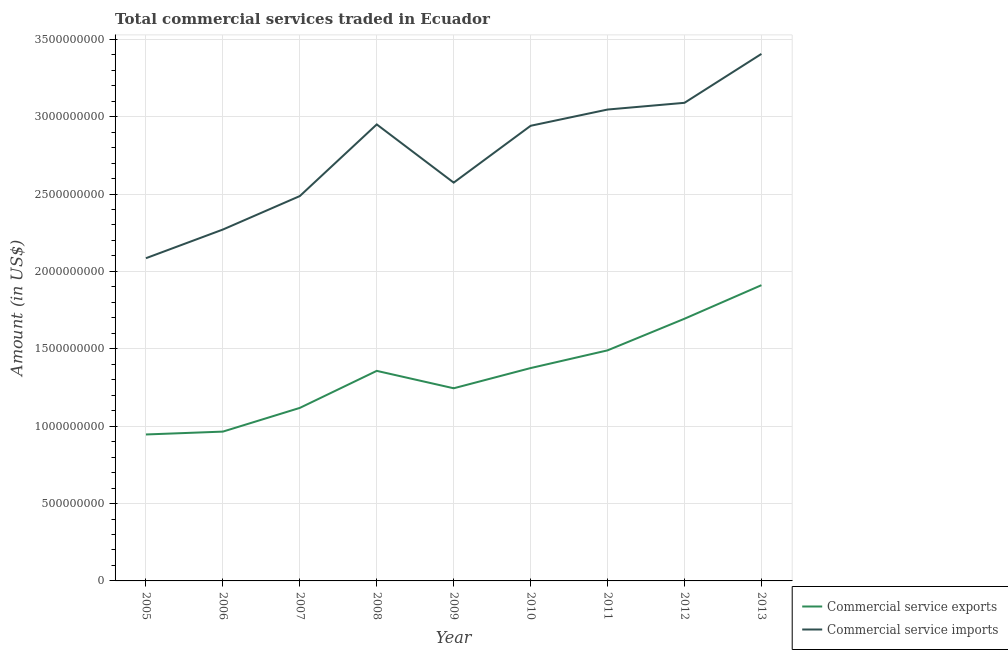How many different coloured lines are there?
Offer a very short reply. 2. Does the line corresponding to amount of commercial service imports intersect with the line corresponding to amount of commercial service exports?
Give a very brief answer. No. Is the number of lines equal to the number of legend labels?
Offer a terse response. Yes. What is the amount of commercial service exports in 2007?
Provide a short and direct response. 1.12e+09. Across all years, what is the maximum amount of commercial service exports?
Your response must be concise. 1.91e+09. Across all years, what is the minimum amount of commercial service imports?
Provide a succinct answer. 2.09e+09. In which year was the amount of commercial service exports maximum?
Make the answer very short. 2013. What is the total amount of commercial service imports in the graph?
Provide a succinct answer. 2.48e+1. What is the difference between the amount of commercial service imports in 2007 and that in 2012?
Your answer should be compact. -6.03e+08. What is the difference between the amount of commercial service imports in 2011 and the amount of commercial service exports in 2009?
Provide a short and direct response. 1.80e+09. What is the average amount of commercial service exports per year?
Keep it short and to the point. 1.34e+09. In the year 2005, what is the difference between the amount of commercial service exports and amount of commercial service imports?
Offer a terse response. -1.14e+09. What is the ratio of the amount of commercial service imports in 2008 to that in 2011?
Offer a terse response. 0.97. What is the difference between the highest and the second highest amount of commercial service exports?
Offer a very short reply. 2.17e+08. What is the difference between the highest and the lowest amount of commercial service imports?
Offer a very short reply. 1.32e+09. Is the sum of the amount of commercial service exports in 2006 and 2009 greater than the maximum amount of commercial service imports across all years?
Your answer should be very brief. No. Does the amount of commercial service imports monotonically increase over the years?
Keep it short and to the point. No. How many lines are there?
Your answer should be compact. 2. Does the graph contain any zero values?
Your response must be concise. No. Does the graph contain grids?
Your response must be concise. Yes. Where does the legend appear in the graph?
Your answer should be compact. Bottom right. What is the title of the graph?
Ensure brevity in your answer.  Total commercial services traded in Ecuador. What is the label or title of the X-axis?
Give a very brief answer. Year. What is the Amount (in US$) of Commercial service exports in 2005?
Give a very brief answer. 9.46e+08. What is the Amount (in US$) in Commercial service imports in 2005?
Make the answer very short. 2.09e+09. What is the Amount (in US$) in Commercial service exports in 2006?
Keep it short and to the point. 9.65e+08. What is the Amount (in US$) of Commercial service imports in 2006?
Keep it short and to the point. 2.27e+09. What is the Amount (in US$) of Commercial service exports in 2007?
Keep it short and to the point. 1.12e+09. What is the Amount (in US$) in Commercial service imports in 2007?
Your answer should be compact. 2.49e+09. What is the Amount (in US$) in Commercial service exports in 2008?
Ensure brevity in your answer.  1.36e+09. What is the Amount (in US$) in Commercial service imports in 2008?
Provide a short and direct response. 2.95e+09. What is the Amount (in US$) in Commercial service exports in 2009?
Offer a very short reply. 1.24e+09. What is the Amount (in US$) in Commercial service imports in 2009?
Give a very brief answer. 2.57e+09. What is the Amount (in US$) in Commercial service exports in 2010?
Your response must be concise. 1.38e+09. What is the Amount (in US$) in Commercial service imports in 2010?
Your answer should be very brief. 2.94e+09. What is the Amount (in US$) in Commercial service exports in 2011?
Your response must be concise. 1.49e+09. What is the Amount (in US$) of Commercial service imports in 2011?
Ensure brevity in your answer.  3.05e+09. What is the Amount (in US$) of Commercial service exports in 2012?
Ensure brevity in your answer.  1.69e+09. What is the Amount (in US$) of Commercial service imports in 2012?
Offer a very short reply. 3.09e+09. What is the Amount (in US$) in Commercial service exports in 2013?
Your answer should be very brief. 1.91e+09. What is the Amount (in US$) of Commercial service imports in 2013?
Your answer should be very brief. 3.41e+09. Across all years, what is the maximum Amount (in US$) in Commercial service exports?
Your answer should be very brief. 1.91e+09. Across all years, what is the maximum Amount (in US$) of Commercial service imports?
Make the answer very short. 3.41e+09. Across all years, what is the minimum Amount (in US$) in Commercial service exports?
Offer a terse response. 9.46e+08. Across all years, what is the minimum Amount (in US$) in Commercial service imports?
Give a very brief answer. 2.09e+09. What is the total Amount (in US$) in Commercial service exports in the graph?
Offer a very short reply. 1.21e+1. What is the total Amount (in US$) of Commercial service imports in the graph?
Your answer should be very brief. 2.48e+1. What is the difference between the Amount (in US$) in Commercial service exports in 2005 and that in 2006?
Ensure brevity in your answer.  -1.85e+07. What is the difference between the Amount (in US$) of Commercial service imports in 2005 and that in 2006?
Your response must be concise. -1.85e+08. What is the difference between the Amount (in US$) in Commercial service exports in 2005 and that in 2007?
Offer a very short reply. -1.72e+08. What is the difference between the Amount (in US$) in Commercial service imports in 2005 and that in 2007?
Your answer should be compact. -4.02e+08. What is the difference between the Amount (in US$) in Commercial service exports in 2005 and that in 2008?
Ensure brevity in your answer.  -4.11e+08. What is the difference between the Amount (in US$) of Commercial service imports in 2005 and that in 2008?
Make the answer very short. -8.64e+08. What is the difference between the Amount (in US$) in Commercial service exports in 2005 and that in 2009?
Offer a very short reply. -2.99e+08. What is the difference between the Amount (in US$) of Commercial service imports in 2005 and that in 2009?
Your answer should be compact. -4.88e+08. What is the difference between the Amount (in US$) of Commercial service exports in 2005 and that in 2010?
Your response must be concise. -4.29e+08. What is the difference between the Amount (in US$) of Commercial service imports in 2005 and that in 2010?
Make the answer very short. -8.56e+08. What is the difference between the Amount (in US$) in Commercial service exports in 2005 and that in 2011?
Keep it short and to the point. -5.44e+08. What is the difference between the Amount (in US$) of Commercial service imports in 2005 and that in 2011?
Your answer should be very brief. -9.61e+08. What is the difference between the Amount (in US$) in Commercial service exports in 2005 and that in 2012?
Keep it short and to the point. -7.48e+08. What is the difference between the Amount (in US$) in Commercial service imports in 2005 and that in 2012?
Give a very brief answer. -1.00e+09. What is the difference between the Amount (in US$) in Commercial service exports in 2005 and that in 2013?
Offer a very short reply. -9.65e+08. What is the difference between the Amount (in US$) in Commercial service imports in 2005 and that in 2013?
Provide a succinct answer. -1.32e+09. What is the difference between the Amount (in US$) of Commercial service exports in 2006 and that in 2007?
Provide a short and direct response. -1.53e+08. What is the difference between the Amount (in US$) in Commercial service imports in 2006 and that in 2007?
Keep it short and to the point. -2.16e+08. What is the difference between the Amount (in US$) of Commercial service exports in 2006 and that in 2008?
Offer a very short reply. -3.93e+08. What is the difference between the Amount (in US$) in Commercial service imports in 2006 and that in 2008?
Offer a very short reply. -6.79e+08. What is the difference between the Amount (in US$) in Commercial service exports in 2006 and that in 2009?
Ensure brevity in your answer.  -2.80e+08. What is the difference between the Amount (in US$) in Commercial service imports in 2006 and that in 2009?
Give a very brief answer. -3.03e+08. What is the difference between the Amount (in US$) of Commercial service exports in 2006 and that in 2010?
Offer a very short reply. -4.11e+08. What is the difference between the Amount (in US$) in Commercial service imports in 2006 and that in 2010?
Provide a succinct answer. -6.70e+08. What is the difference between the Amount (in US$) in Commercial service exports in 2006 and that in 2011?
Offer a very short reply. -5.25e+08. What is the difference between the Amount (in US$) of Commercial service imports in 2006 and that in 2011?
Give a very brief answer. -7.75e+08. What is the difference between the Amount (in US$) of Commercial service exports in 2006 and that in 2012?
Ensure brevity in your answer.  -7.29e+08. What is the difference between the Amount (in US$) in Commercial service imports in 2006 and that in 2012?
Provide a short and direct response. -8.19e+08. What is the difference between the Amount (in US$) in Commercial service exports in 2006 and that in 2013?
Keep it short and to the point. -9.46e+08. What is the difference between the Amount (in US$) of Commercial service imports in 2006 and that in 2013?
Your answer should be compact. -1.13e+09. What is the difference between the Amount (in US$) of Commercial service exports in 2007 and that in 2008?
Your answer should be very brief. -2.39e+08. What is the difference between the Amount (in US$) of Commercial service imports in 2007 and that in 2008?
Ensure brevity in your answer.  -4.63e+08. What is the difference between the Amount (in US$) in Commercial service exports in 2007 and that in 2009?
Keep it short and to the point. -1.27e+08. What is the difference between the Amount (in US$) of Commercial service imports in 2007 and that in 2009?
Your answer should be very brief. -8.68e+07. What is the difference between the Amount (in US$) of Commercial service exports in 2007 and that in 2010?
Ensure brevity in your answer.  -2.57e+08. What is the difference between the Amount (in US$) in Commercial service imports in 2007 and that in 2010?
Ensure brevity in your answer.  -4.54e+08. What is the difference between the Amount (in US$) in Commercial service exports in 2007 and that in 2011?
Give a very brief answer. -3.72e+08. What is the difference between the Amount (in US$) of Commercial service imports in 2007 and that in 2011?
Give a very brief answer. -5.59e+08. What is the difference between the Amount (in US$) in Commercial service exports in 2007 and that in 2012?
Your answer should be very brief. -5.76e+08. What is the difference between the Amount (in US$) of Commercial service imports in 2007 and that in 2012?
Provide a short and direct response. -6.03e+08. What is the difference between the Amount (in US$) in Commercial service exports in 2007 and that in 2013?
Make the answer very short. -7.93e+08. What is the difference between the Amount (in US$) in Commercial service imports in 2007 and that in 2013?
Your answer should be compact. -9.19e+08. What is the difference between the Amount (in US$) in Commercial service exports in 2008 and that in 2009?
Your response must be concise. 1.13e+08. What is the difference between the Amount (in US$) of Commercial service imports in 2008 and that in 2009?
Keep it short and to the point. 3.76e+08. What is the difference between the Amount (in US$) in Commercial service exports in 2008 and that in 2010?
Provide a short and direct response. -1.81e+07. What is the difference between the Amount (in US$) in Commercial service imports in 2008 and that in 2010?
Give a very brief answer. 8.76e+06. What is the difference between the Amount (in US$) in Commercial service exports in 2008 and that in 2011?
Keep it short and to the point. -1.32e+08. What is the difference between the Amount (in US$) in Commercial service imports in 2008 and that in 2011?
Provide a short and direct response. -9.62e+07. What is the difference between the Amount (in US$) of Commercial service exports in 2008 and that in 2012?
Give a very brief answer. -3.37e+08. What is the difference between the Amount (in US$) in Commercial service imports in 2008 and that in 2012?
Your response must be concise. -1.40e+08. What is the difference between the Amount (in US$) of Commercial service exports in 2008 and that in 2013?
Give a very brief answer. -5.54e+08. What is the difference between the Amount (in US$) in Commercial service imports in 2008 and that in 2013?
Make the answer very short. -4.56e+08. What is the difference between the Amount (in US$) in Commercial service exports in 2009 and that in 2010?
Keep it short and to the point. -1.31e+08. What is the difference between the Amount (in US$) in Commercial service imports in 2009 and that in 2010?
Your answer should be compact. -3.67e+08. What is the difference between the Amount (in US$) of Commercial service exports in 2009 and that in 2011?
Offer a very short reply. -2.45e+08. What is the difference between the Amount (in US$) of Commercial service imports in 2009 and that in 2011?
Your answer should be very brief. -4.72e+08. What is the difference between the Amount (in US$) in Commercial service exports in 2009 and that in 2012?
Give a very brief answer. -4.49e+08. What is the difference between the Amount (in US$) in Commercial service imports in 2009 and that in 2012?
Offer a terse response. -5.16e+08. What is the difference between the Amount (in US$) of Commercial service exports in 2009 and that in 2013?
Make the answer very short. -6.66e+08. What is the difference between the Amount (in US$) of Commercial service imports in 2009 and that in 2013?
Give a very brief answer. -8.32e+08. What is the difference between the Amount (in US$) of Commercial service exports in 2010 and that in 2011?
Give a very brief answer. -1.14e+08. What is the difference between the Amount (in US$) in Commercial service imports in 2010 and that in 2011?
Your answer should be very brief. -1.05e+08. What is the difference between the Amount (in US$) in Commercial service exports in 2010 and that in 2012?
Give a very brief answer. -3.19e+08. What is the difference between the Amount (in US$) in Commercial service imports in 2010 and that in 2012?
Make the answer very short. -1.48e+08. What is the difference between the Amount (in US$) of Commercial service exports in 2010 and that in 2013?
Your answer should be compact. -5.36e+08. What is the difference between the Amount (in US$) of Commercial service imports in 2010 and that in 2013?
Make the answer very short. -4.64e+08. What is the difference between the Amount (in US$) in Commercial service exports in 2011 and that in 2012?
Ensure brevity in your answer.  -2.04e+08. What is the difference between the Amount (in US$) of Commercial service imports in 2011 and that in 2012?
Keep it short and to the point. -4.35e+07. What is the difference between the Amount (in US$) in Commercial service exports in 2011 and that in 2013?
Your answer should be compact. -4.21e+08. What is the difference between the Amount (in US$) in Commercial service imports in 2011 and that in 2013?
Your answer should be compact. -3.59e+08. What is the difference between the Amount (in US$) of Commercial service exports in 2012 and that in 2013?
Ensure brevity in your answer.  -2.17e+08. What is the difference between the Amount (in US$) in Commercial service imports in 2012 and that in 2013?
Your answer should be very brief. -3.16e+08. What is the difference between the Amount (in US$) of Commercial service exports in 2005 and the Amount (in US$) of Commercial service imports in 2006?
Ensure brevity in your answer.  -1.32e+09. What is the difference between the Amount (in US$) of Commercial service exports in 2005 and the Amount (in US$) of Commercial service imports in 2007?
Offer a terse response. -1.54e+09. What is the difference between the Amount (in US$) of Commercial service exports in 2005 and the Amount (in US$) of Commercial service imports in 2008?
Keep it short and to the point. -2.00e+09. What is the difference between the Amount (in US$) in Commercial service exports in 2005 and the Amount (in US$) in Commercial service imports in 2009?
Ensure brevity in your answer.  -1.63e+09. What is the difference between the Amount (in US$) in Commercial service exports in 2005 and the Amount (in US$) in Commercial service imports in 2010?
Make the answer very short. -1.99e+09. What is the difference between the Amount (in US$) of Commercial service exports in 2005 and the Amount (in US$) of Commercial service imports in 2011?
Keep it short and to the point. -2.10e+09. What is the difference between the Amount (in US$) of Commercial service exports in 2005 and the Amount (in US$) of Commercial service imports in 2012?
Your answer should be compact. -2.14e+09. What is the difference between the Amount (in US$) of Commercial service exports in 2005 and the Amount (in US$) of Commercial service imports in 2013?
Keep it short and to the point. -2.46e+09. What is the difference between the Amount (in US$) of Commercial service exports in 2006 and the Amount (in US$) of Commercial service imports in 2007?
Your answer should be very brief. -1.52e+09. What is the difference between the Amount (in US$) of Commercial service exports in 2006 and the Amount (in US$) of Commercial service imports in 2008?
Give a very brief answer. -1.99e+09. What is the difference between the Amount (in US$) in Commercial service exports in 2006 and the Amount (in US$) in Commercial service imports in 2009?
Offer a terse response. -1.61e+09. What is the difference between the Amount (in US$) in Commercial service exports in 2006 and the Amount (in US$) in Commercial service imports in 2010?
Your response must be concise. -1.98e+09. What is the difference between the Amount (in US$) of Commercial service exports in 2006 and the Amount (in US$) of Commercial service imports in 2011?
Offer a very short reply. -2.08e+09. What is the difference between the Amount (in US$) in Commercial service exports in 2006 and the Amount (in US$) in Commercial service imports in 2012?
Offer a very short reply. -2.12e+09. What is the difference between the Amount (in US$) in Commercial service exports in 2006 and the Amount (in US$) in Commercial service imports in 2013?
Give a very brief answer. -2.44e+09. What is the difference between the Amount (in US$) in Commercial service exports in 2007 and the Amount (in US$) in Commercial service imports in 2008?
Offer a very short reply. -1.83e+09. What is the difference between the Amount (in US$) in Commercial service exports in 2007 and the Amount (in US$) in Commercial service imports in 2009?
Your answer should be very brief. -1.46e+09. What is the difference between the Amount (in US$) of Commercial service exports in 2007 and the Amount (in US$) of Commercial service imports in 2010?
Give a very brief answer. -1.82e+09. What is the difference between the Amount (in US$) in Commercial service exports in 2007 and the Amount (in US$) in Commercial service imports in 2011?
Make the answer very short. -1.93e+09. What is the difference between the Amount (in US$) of Commercial service exports in 2007 and the Amount (in US$) of Commercial service imports in 2012?
Offer a very short reply. -1.97e+09. What is the difference between the Amount (in US$) in Commercial service exports in 2007 and the Amount (in US$) in Commercial service imports in 2013?
Your answer should be very brief. -2.29e+09. What is the difference between the Amount (in US$) of Commercial service exports in 2008 and the Amount (in US$) of Commercial service imports in 2009?
Provide a short and direct response. -1.22e+09. What is the difference between the Amount (in US$) in Commercial service exports in 2008 and the Amount (in US$) in Commercial service imports in 2010?
Make the answer very short. -1.58e+09. What is the difference between the Amount (in US$) of Commercial service exports in 2008 and the Amount (in US$) of Commercial service imports in 2011?
Offer a very short reply. -1.69e+09. What is the difference between the Amount (in US$) of Commercial service exports in 2008 and the Amount (in US$) of Commercial service imports in 2012?
Your answer should be very brief. -1.73e+09. What is the difference between the Amount (in US$) in Commercial service exports in 2008 and the Amount (in US$) in Commercial service imports in 2013?
Make the answer very short. -2.05e+09. What is the difference between the Amount (in US$) in Commercial service exports in 2009 and the Amount (in US$) in Commercial service imports in 2010?
Provide a succinct answer. -1.70e+09. What is the difference between the Amount (in US$) in Commercial service exports in 2009 and the Amount (in US$) in Commercial service imports in 2011?
Provide a short and direct response. -1.80e+09. What is the difference between the Amount (in US$) in Commercial service exports in 2009 and the Amount (in US$) in Commercial service imports in 2012?
Your response must be concise. -1.84e+09. What is the difference between the Amount (in US$) in Commercial service exports in 2009 and the Amount (in US$) in Commercial service imports in 2013?
Provide a succinct answer. -2.16e+09. What is the difference between the Amount (in US$) in Commercial service exports in 2010 and the Amount (in US$) in Commercial service imports in 2011?
Provide a short and direct response. -1.67e+09. What is the difference between the Amount (in US$) of Commercial service exports in 2010 and the Amount (in US$) of Commercial service imports in 2012?
Give a very brief answer. -1.71e+09. What is the difference between the Amount (in US$) of Commercial service exports in 2010 and the Amount (in US$) of Commercial service imports in 2013?
Your answer should be compact. -2.03e+09. What is the difference between the Amount (in US$) of Commercial service exports in 2011 and the Amount (in US$) of Commercial service imports in 2012?
Ensure brevity in your answer.  -1.60e+09. What is the difference between the Amount (in US$) of Commercial service exports in 2011 and the Amount (in US$) of Commercial service imports in 2013?
Provide a short and direct response. -1.92e+09. What is the difference between the Amount (in US$) in Commercial service exports in 2012 and the Amount (in US$) in Commercial service imports in 2013?
Your answer should be very brief. -1.71e+09. What is the average Amount (in US$) of Commercial service exports per year?
Offer a very short reply. 1.34e+09. What is the average Amount (in US$) of Commercial service imports per year?
Your answer should be very brief. 2.76e+09. In the year 2005, what is the difference between the Amount (in US$) in Commercial service exports and Amount (in US$) in Commercial service imports?
Your answer should be compact. -1.14e+09. In the year 2006, what is the difference between the Amount (in US$) of Commercial service exports and Amount (in US$) of Commercial service imports?
Your answer should be very brief. -1.31e+09. In the year 2007, what is the difference between the Amount (in US$) in Commercial service exports and Amount (in US$) in Commercial service imports?
Your answer should be very brief. -1.37e+09. In the year 2008, what is the difference between the Amount (in US$) in Commercial service exports and Amount (in US$) in Commercial service imports?
Provide a short and direct response. -1.59e+09. In the year 2009, what is the difference between the Amount (in US$) of Commercial service exports and Amount (in US$) of Commercial service imports?
Keep it short and to the point. -1.33e+09. In the year 2010, what is the difference between the Amount (in US$) in Commercial service exports and Amount (in US$) in Commercial service imports?
Give a very brief answer. -1.57e+09. In the year 2011, what is the difference between the Amount (in US$) in Commercial service exports and Amount (in US$) in Commercial service imports?
Your answer should be very brief. -1.56e+09. In the year 2012, what is the difference between the Amount (in US$) of Commercial service exports and Amount (in US$) of Commercial service imports?
Ensure brevity in your answer.  -1.40e+09. In the year 2013, what is the difference between the Amount (in US$) of Commercial service exports and Amount (in US$) of Commercial service imports?
Offer a very short reply. -1.49e+09. What is the ratio of the Amount (in US$) of Commercial service exports in 2005 to that in 2006?
Your answer should be very brief. 0.98. What is the ratio of the Amount (in US$) in Commercial service imports in 2005 to that in 2006?
Give a very brief answer. 0.92. What is the ratio of the Amount (in US$) in Commercial service exports in 2005 to that in 2007?
Provide a succinct answer. 0.85. What is the ratio of the Amount (in US$) in Commercial service imports in 2005 to that in 2007?
Your answer should be compact. 0.84. What is the ratio of the Amount (in US$) in Commercial service exports in 2005 to that in 2008?
Ensure brevity in your answer.  0.7. What is the ratio of the Amount (in US$) of Commercial service imports in 2005 to that in 2008?
Provide a short and direct response. 0.71. What is the ratio of the Amount (in US$) of Commercial service exports in 2005 to that in 2009?
Keep it short and to the point. 0.76. What is the ratio of the Amount (in US$) in Commercial service imports in 2005 to that in 2009?
Provide a succinct answer. 0.81. What is the ratio of the Amount (in US$) in Commercial service exports in 2005 to that in 2010?
Ensure brevity in your answer.  0.69. What is the ratio of the Amount (in US$) of Commercial service imports in 2005 to that in 2010?
Offer a very short reply. 0.71. What is the ratio of the Amount (in US$) of Commercial service exports in 2005 to that in 2011?
Provide a succinct answer. 0.64. What is the ratio of the Amount (in US$) of Commercial service imports in 2005 to that in 2011?
Provide a succinct answer. 0.68. What is the ratio of the Amount (in US$) in Commercial service exports in 2005 to that in 2012?
Provide a succinct answer. 0.56. What is the ratio of the Amount (in US$) of Commercial service imports in 2005 to that in 2012?
Your answer should be compact. 0.68. What is the ratio of the Amount (in US$) of Commercial service exports in 2005 to that in 2013?
Your response must be concise. 0.5. What is the ratio of the Amount (in US$) in Commercial service imports in 2005 to that in 2013?
Your answer should be compact. 0.61. What is the ratio of the Amount (in US$) of Commercial service exports in 2006 to that in 2007?
Your answer should be compact. 0.86. What is the ratio of the Amount (in US$) of Commercial service exports in 2006 to that in 2008?
Ensure brevity in your answer.  0.71. What is the ratio of the Amount (in US$) in Commercial service imports in 2006 to that in 2008?
Offer a very short reply. 0.77. What is the ratio of the Amount (in US$) in Commercial service exports in 2006 to that in 2009?
Your answer should be compact. 0.78. What is the ratio of the Amount (in US$) in Commercial service imports in 2006 to that in 2009?
Your response must be concise. 0.88. What is the ratio of the Amount (in US$) in Commercial service exports in 2006 to that in 2010?
Your response must be concise. 0.7. What is the ratio of the Amount (in US$) in Commercial service imports in 2006 to that in 2010?
Your answer should be very brief. 0.77. What is the ratio of the Amount (in US$) in Commercial service exports in 2006 to that in 2011?
Offer a terse response. 0.65. What is the ratio of the Amount (in US$) of Commercial service imports in 2006 to that in 2011?
Your response must be concise. 0.75. What is the ratio of the Amount (in US$) of Commercial service exports in 2006 to that in 2012?
Make the answer very short. 0.57. What is the ratio of the Amount (in US$) of Commercial service imports in 2006 to that in 2012?
Ensure brevity in your answer.  0.73. What is the ratio of the Amount (in US$) of Commercial service exports in 2006 to that in 2013?
Offer a very short reply. 0.5. What is the ratio of the Amount (in US$) in Commercial service exports in 2007 to that in 2008?
Keep it short and to the point. 0.82. What is the ratio of the Amount (in US$) in Commercial service imports in 2007 to that in 2008?
Make the answer very short. 0.84. What is the ratio of the Amount (in US$) of Commercial service exports in 2007 to that in 2009?
Offer a very short reply. 0.9. What is the ratio of the Amount (in US$) in Commercial service imports in 2007 to that in 2009?
Offer a terse response. 0.97. What is the ratio of the Amount (in US$) of Commercial service exports in 2007 to that in 2010?
Make the answer very short. 0.81. What is the ratio of the Amount (in US$) in Commercial service imports in 2007 to that in 2010?
Give a very brief answer. 0.85. What is the ratio of the Amount (in US$) of Commercial service exports in 2007 to that in 2011?
Your answer should be very brief. 0.75. What is the ratio of the Amount (in US$) in Commercial service imports in 2007 to that in 2011?
Give a very brief answer. 0.82. What is the ratio of the Amount (in US$) of Commercial service exports in 2007 to that in 2012?
Your answer should be compact. 0.66. What is the ratio of the Amount (in US$) in Commercial service imports in 2007 to that in 2012?
Make the answer very short. 0.81. What is the ratio of the Amount (in US$) in Commercial service exports in 2007 to that in 2013?
Offer a terse response. 0.58. What is the ratio of the Amount (in US$) of Commercial service imports in 2007 to that in 2013?
Offer a very short reply. 0.73. What is the ratio of the Amount (in US$) of Commercial service exports in 2008 to that in 2009?
Your response must be concise. 1.09. What is the ratio of the Amount (in US$) of Commercial service imports in 2008 to that in 2009?
Offer a terse response. 1.15. What is the ratio of the Amount (in US$) in Commercial service exports in 2008 to that in 2010?
Provide a succinct answer. 0.99. What is the ratio of the Amount (in US$) in Commercial service exports in 2008 to that in 2011?
Provide a succinct answer. 0.91. What is the ratio of the Amount (in US$) of Commercial service imports in 2008 to that in 2011?
Your response must be concise. 0.97. What is the ratio of the Amount (in US$) of Commercial service exports in 2008 to that in 2012?
Your answer should be very brief. 0.8. What is the ratio of the Amount (in US$) of Commercial service imports in 2008 to that in 2012?
Offer a very short reply. 0.95. What is the ratio of the Amount (in US$) of Commercial service exports in 2008 to that in 2013?
Provide a succinct answer. 0.71. What is the ratio of the Amount (in US$) in Commercial service imports in 2008 to that in 2013?
Your answer should be very brief. 0.87. What is the ratio of the Amount (in US$) in Commercial service exports in 2009 to that in 2010?
Your answer should be compact. 0.91. What is the ratio of the Amount (in US$) in Commercial service imports in 2009 to that in 2010?
Provide a short and direct response. 0.88. What is the ratio of the Amount (in US$) of Commercial service exports in 2009 to that in 2011?
Your answer should be compact. 0.84. What is the ratio of the Amount (in US$) of Commercial service imports in 2009 to that in 2011?
Ensure brevity in your answer.  0.84. What is the ratio of the Amount (in US$) of Commercial service exports in 2009 to that in 2012?
Ensure brevity in your answer.  0.73. What is the ratio of the Amount (in US$) in Commercial service imports in 2009 to that in 2012?
Make the answer very short. 0.83. What is the ratio of the Amount (in US$) in Commercial service exports in 2009 to that in 2013?
Offer a terse response. 0.65. What is the ratio of the Amount (in US$) of Commercial service imports in 2009 to that in 2013?
Ensure brevity in your answer.  0.76. What is the ratio of the Amount (in US$) in Commercial service exports in 2010 to that in 2011?
Keep it short and to the point. 0.92. What is the ratio of the Amount (in US$) in Commercial service imports in 2010 to that in 2011?
Provide a succinct answer. 0.97. What is the ratio of the Amount (in US$) of Commercial service exports in 2010 to that in 2012?
Provide a succinct answer. 0.81. What is the ratio of the Amount (in US$) of Commercial service imports in 2010 to that in 2012?
Your answer should be very brief. 0.95. What is the ratio of the Amount (in US$) in Commercial service exports in 2010 to that in 2013?
Keep it short and to the point. 0.72. What is the ratio of the Amount (in US$) of Commercial service imports in 2010 to that in 2013?
Your answer should be very brief. 0.86. What is the ratio of the Amount (in US$) in Commercial service exports in 2011 to that in 2012?
Make the answer very short. 0.88. What is the ratio of the Amount (in US$) in Commercial service imports in 2011 to that in 2012?
Your response must be concise. 0.99. What is the ratio of the Amount (in US$) in Commercial service exports in 2011 to that in 2013?
Provide a short and direct response. 0.78. What is the ratio of the Amount (in US$) of Commercial service imports in 2011 to that in 2013?
Your answer should be compact. 0.89. What is the ratio of the Amount (in US$) of Commercial service exports in 2012 to that in 2013?
Ensure brevity in your answer.  0.89. What is the ratio of the Amount (in US$) of Commercial service imports in 2012 to that in 2013?
Ensure brevity in your answer.  0.91. What is the difference between the highest and the second highest Amount (in US$) of Commercial service exports?
Provide a succinct answer. 2.17e+08. What is the difference between the highest and the second highest Amount (in US$) of Commercial service imports?
Provide a succinct answer. 3.16e+08. What is the difference between the highest and the lowest Amount (in US$) in Commercial service exports?
Your response must be concise. 9.65e+08. What is the difference between the highest and the lowest Amount (in US$) in Commercial service imports?
Your response must be concise. 1.32e+09. 